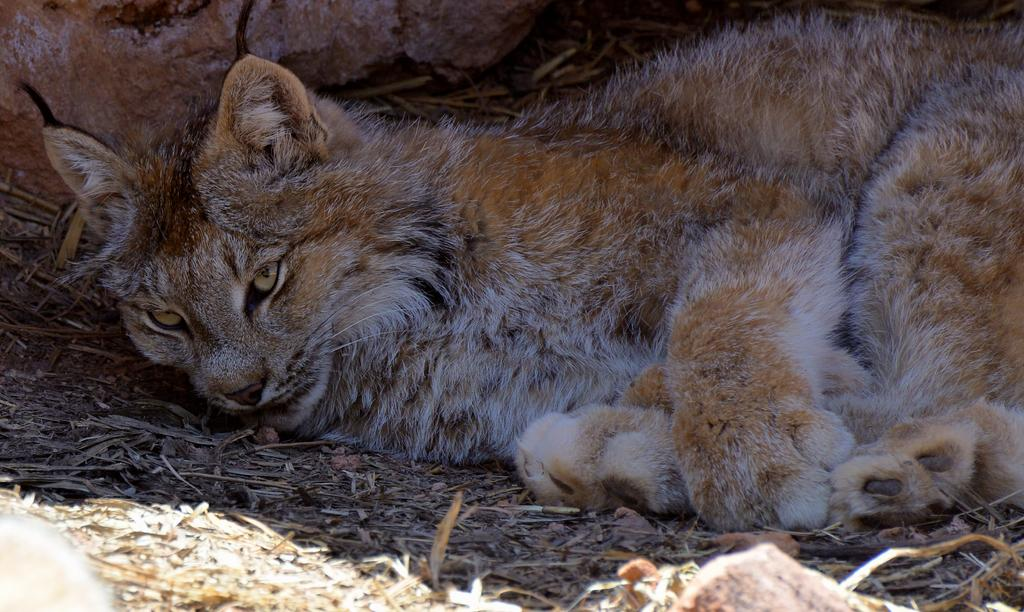What type of animal is in the image? There is a cat in the image. What is the cat doing in the image? The cat is laying on the ground. What other object can be seen in the image? There is a rock in the image. Where is the rock located in the image? The rock is at the top of the image. How many women are present in the image? There are no women present in the image; it features a cat and a rock. What type of throat is visible in the image? There is no throat visible in the image. 